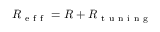<formula> <loc_0><loc_0><loc_500><loc_500>R _ { e f f } = R + R _ { t u n i n g }</formula> 